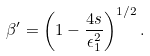<formula> <loc_0><loc_0><loc_500><loc_500>\beta ^ { \prime } = \left ( 1 - \frac { 4 s } { \epsilon ^ { 2 } _ { 1 } } \right ) ^ { 1 / 2 } .</formula> 